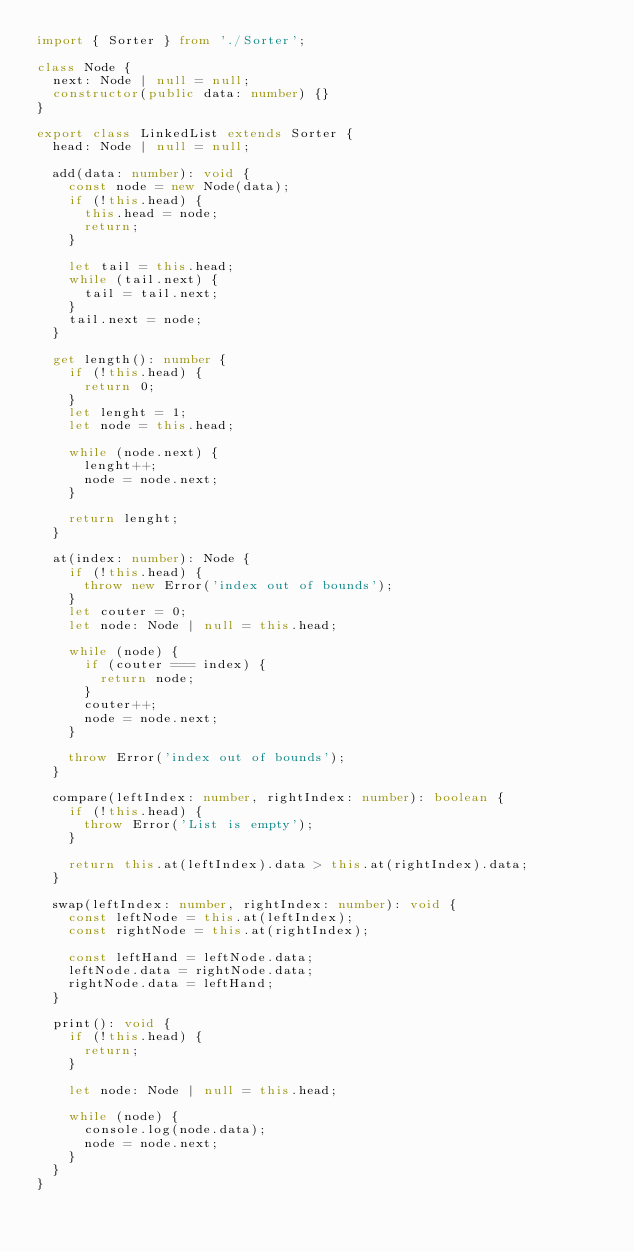Convert code to text. <code><loc_0><loc_0><loc_500><loc_500><_TypeScript_>import { Sorter } from './Sorter';

class Node {
  next: Node | null = null;
  constructor(public data: number) {}
}

export class LinkedList extends Sorter {
  head: Node | null = null;

  add(data: number): void {
    const node = new Node(data);
    if (!this.head) {
      this.head = node;
      return;
    }

    let tail = this.head;
    while (tail.next) {
      tail = tail.next;
    }
    tail.next = node;
  }

  get length(): number {
    if (!this.head) {
      return 0;
    }
    let lenght = 1;
    let node = this.head;

    while (node.next) {
      lenght++;
      node = node.next;
    }

    return lenght;
  }

  at(index: number): Node {
    if (!this.head) {
      throw new Error('index out of bounds');
    }
    let couter = 0;
    let node: Node | null = this.head;

    while (node) {
      if (couter === index) {
        return node;
      }
      couter++;
      node = node.next;
    }

    throw Error('index out of bounds');
  }

  compare(leftIndex: number, rightIndex: number): boolean {
    if (!this.head) {
      throw Error('List is empty');
    }

    return this.at(leftIndex).data > this.at(rightIndex).data;
  }

  swap(leftIndex: number, rightIndex: number): void {
    const leftNode = this.at(leftIndex);
    const rightNode = this.at(rightIndex);

    const leftHand = leftNode.data;
    leftNode.data = rightNode.data;
    rightNode.data = leftHand;
  }

  print(): void {
    if (!this.head) {
      return;
    }

    let node: Node | null = this.head;

    while (node) {
      console.log(node.data);
      node = node.next;
    }
  }
}
</code> 